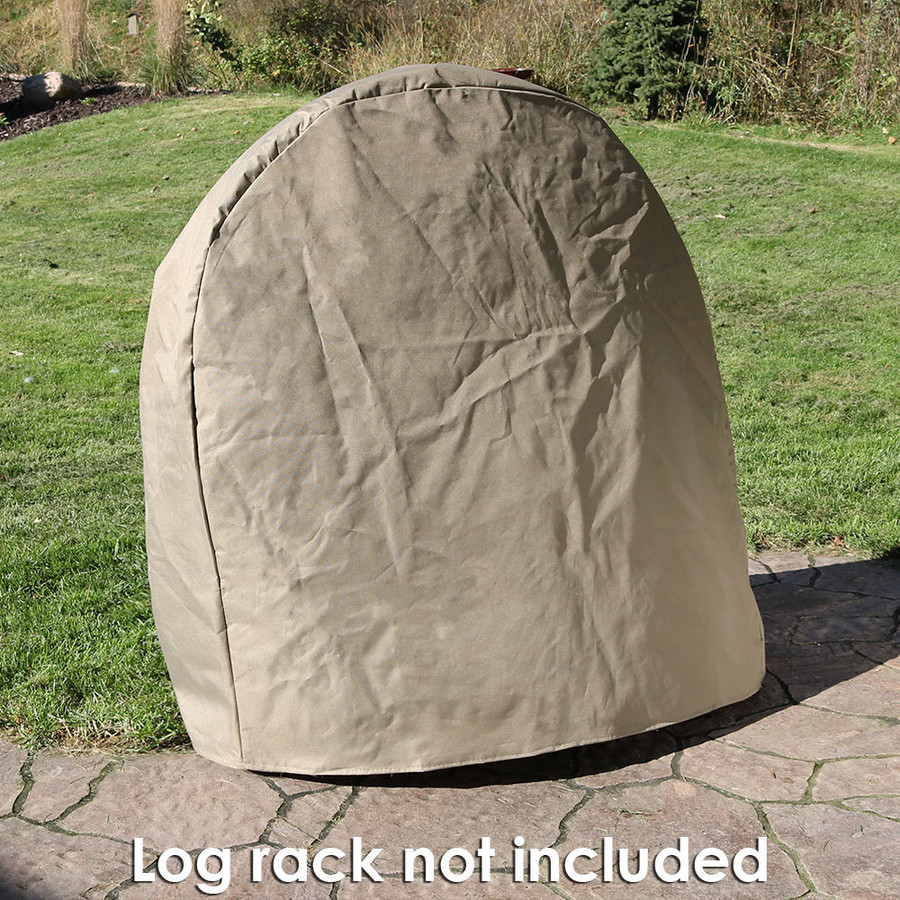What can be the purpose of the cover shown in the image? The cover in the image is typically used to protect outdoor items from weather elements. Given its shape and size, it is likely designed to cover a large rounded object, possibly outdoor furniture or equipment, to shield it from rain, dust, or sunlight, helping to prolong its service life and maintain its condition. 